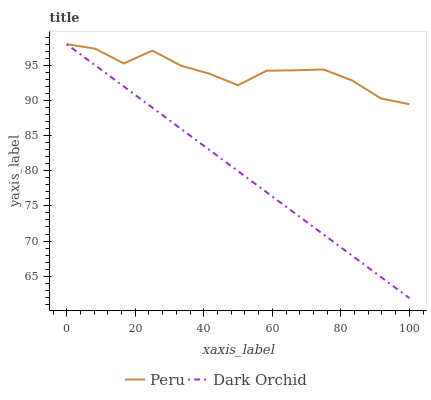Does Dark Orchid have the minimum area under the curve?
Answer yes or no. Yes. Does Peru have the maximum area under the curve?
Answer yes or no. Yes. Does Peru have the minimum area under the curve?
Answer yes or no. No. Is Dark Orchid the smoothest?
Answer yes or no. Yes. Is Peru the roughest?
Answer yes or no. Yes. Is Peru the smoothest?
Answer yes or no. No. Does Dark Orchid have the lowest value?
Answer yes or no. Yes. Does Peru have the lowest value?
Answer yes or no. No. Does Peru have the highest value?
Answer yes or no. Yes. Does Dark Orchid intersect Peru?
Answer yes or no. Yes. Is Dark Orchid less than Peru?
Answer yes or no. No. Is Dark Orchid greater than Peru?
Answer yes or no. No. 